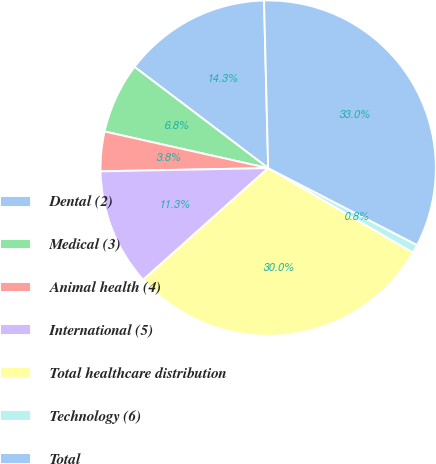Convert chart to OTSL. <chart><loc_0><loc_0><loc_500><loc_500><pie_chart><fcel>Dental (2)<fcel>Medical (3)<fcel>Animal health (4)<fcel>International (5)<fcel>Total healthcare distribution<fcel>Technology (6)<fcel>Total<nl><fcel>14.29%<fcel>6.81%<fcel>3.81%<fcel>11.3%<fcel>29.98%<fcel>0.82%<fcel>32.98%<nl></chart> 